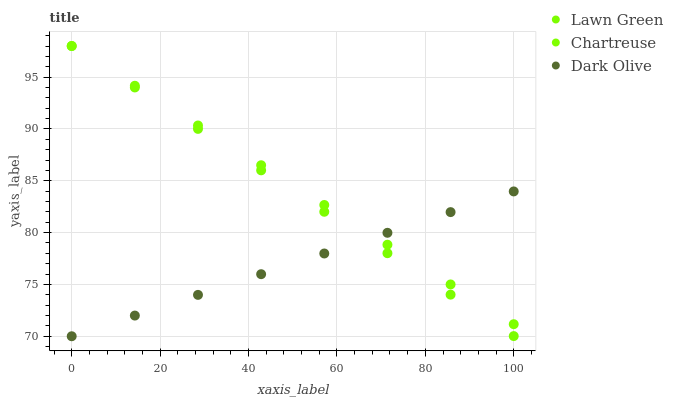Does Dark Olive have the minimum area under the curve?
Answer yes or no. Yes. Does Chartreuse have the maximum area under the curve?
Answer yes or no. Yes. Does Chartreuse have the minimum area under the curve?
Answer yes or no. No. Does Dark Olive have the maximum area under the curve?
Answer yes or no. No. Is Chartreuse the smoothest?
Answer yes or no. Yes. Is Dark Olive the roughest?
Answer yes or no. Yes. Is Dark Olive the smoothest?
Answer yes or no. No. Is Chartreuse the roughest?
Answer yes or no. No. Does Dark Olive have the lowest value?
Answer yes or no. Yes. Does Chartreuse have the lowest value?
Answer yes or no. No. Does Chartreuse have the highest value?
Answer yes or no. Yes. Does Dark Olive have the highest value?
Answer yes or no. No. Does Chartreuse intersect Dark Olive?
Answer yes or no. Yes. Is Chartreuse less than Dark Olive?
Answer yes or no. No. Is Chartreuse greater than Dark Olive?
Answer yes or no. No. 